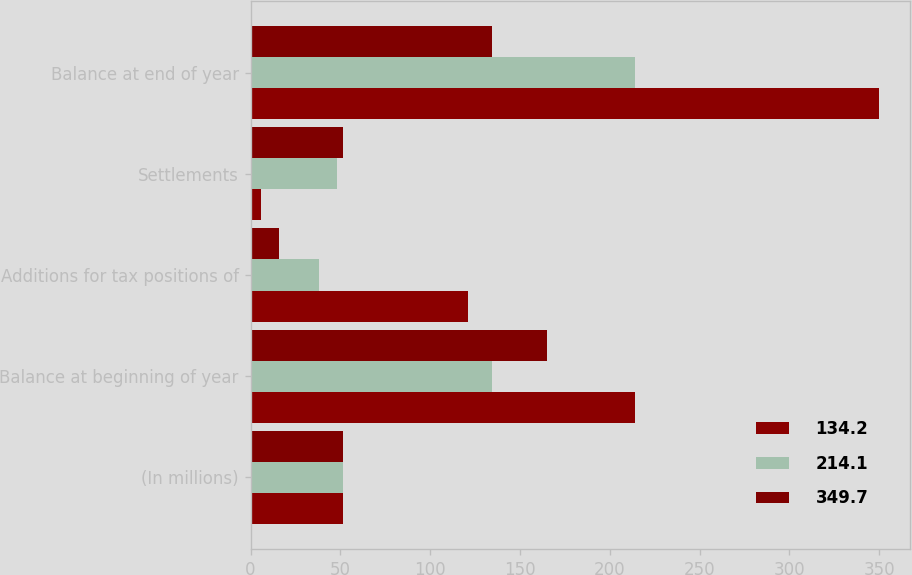Convert chart. <chart><loc_0><loc_0><loc_500><loc_500><stacked_bar_chart><ecel><fcel>(In millions)<fcel>Balance at beginning of year<fcel>Additions for tax positions of<fcel>Settlements<fcel>Balance at end of year<nl><fcel>134.2<fcel>51.6<fcel>214.1<fcel>121.2<fcel>5.6<fcel>349.7<nl><fcel>214.1<fcel>51.6<fcel>134.2<fcel>38.3<fcel>48<fcel>214.1<nl><fcel>349.7<fcel>51.6<fcel>164.8<fcel>15.6<fcel>51.6<fcel>134.2<nl></chart> 